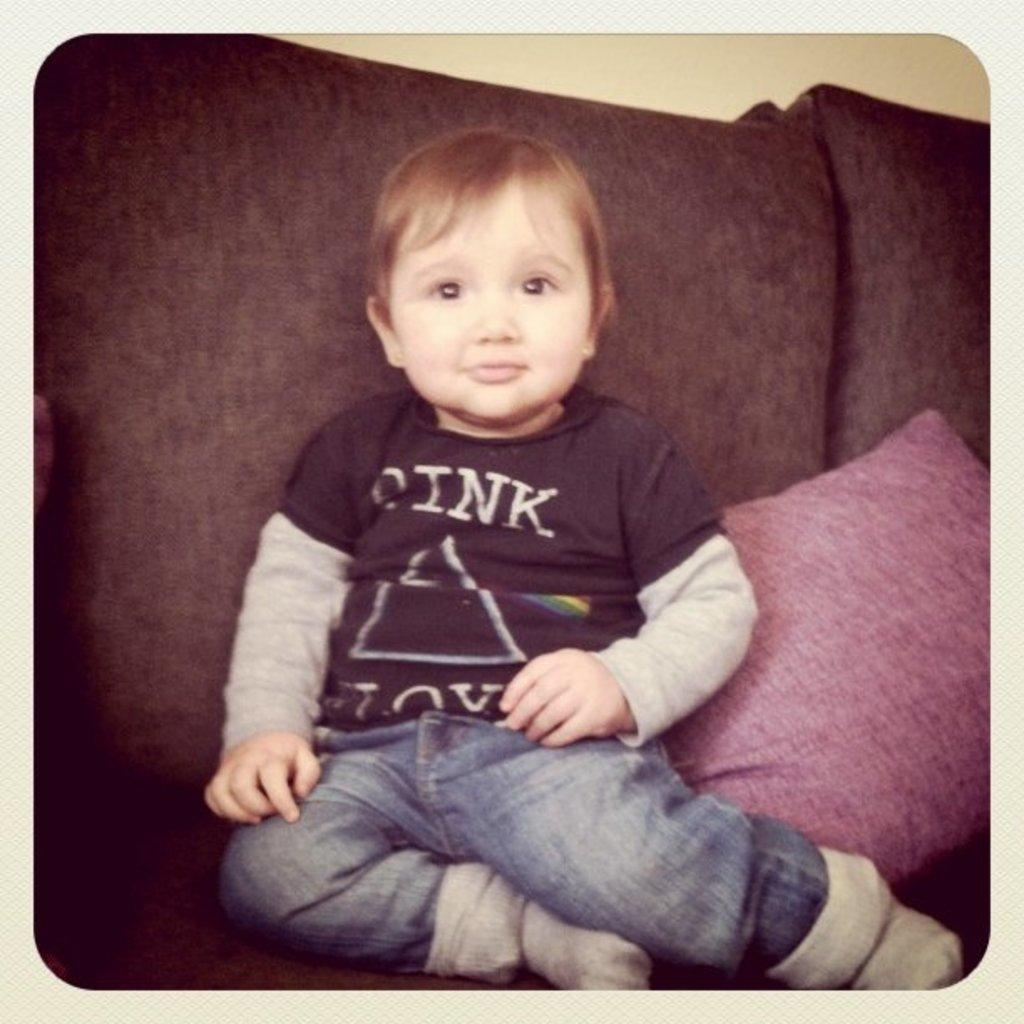Who is present in the image? There is a boy in the image. What is the boy doing in the image? The boy is sitting in the image. What is the boy sitting on? The boy is sitting on a red color sofa. What type of harmony is the boy playing in the image? There is no indication of the boy playing any musical instrument or being involved in any harmony in the image. 